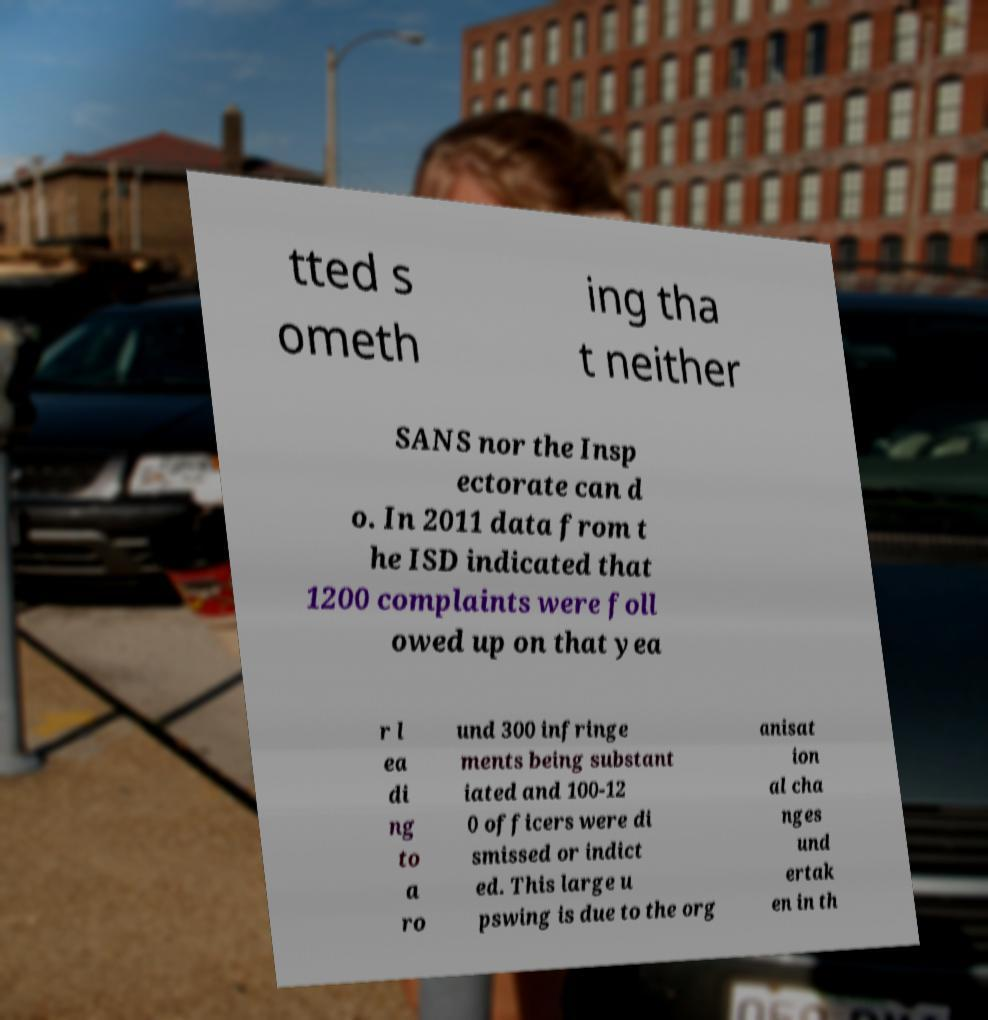Could you extract and type out the text from this image? tted s ometh ing tha t neither SANS nor the Insp ectorate can d o. In 2011 data from t he ISD indicated that 1200 complaints were foll owed up on that yea r l ea di ng to a ro und 300 infringe ments being substant iated and 100-12 0 officers were di smissed or indict ed. This large u pswing is due to the org anisat ion al cha nges und ertak en in th 